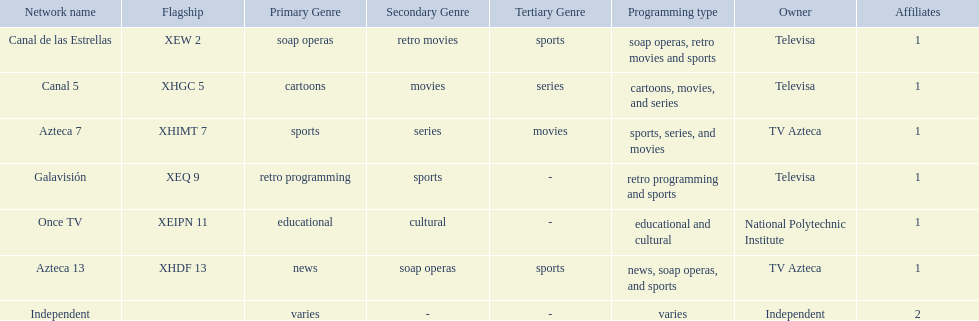What stations show sports? Soap operas, retro movies and sports, retro programming and sports, news, soap operas, and sports. What of these is not affiliated with televisa? Azteca 7. 